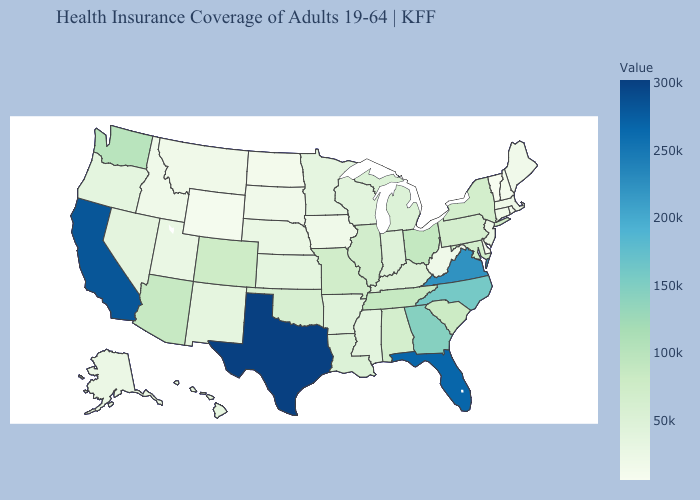Which states have the highest value in the USA?
Answer briefly. Texas. Which states hav the highest value in the MidWest?
Short answer required. Ohio. Among the states that border Vermont , does New Hampshire have the lowest value?
Answer briefly. Yes. Among the states that border North Carolina , which have the lowest value?
Keep it brief. South Carolina. Which states have the lowest value in the USA?
Give a very brief answer. Vermont. Does the map have missing data?
Short answer required. No. Does North Carolina have a lower value than Florida?
Write a very short answer. Yes. 